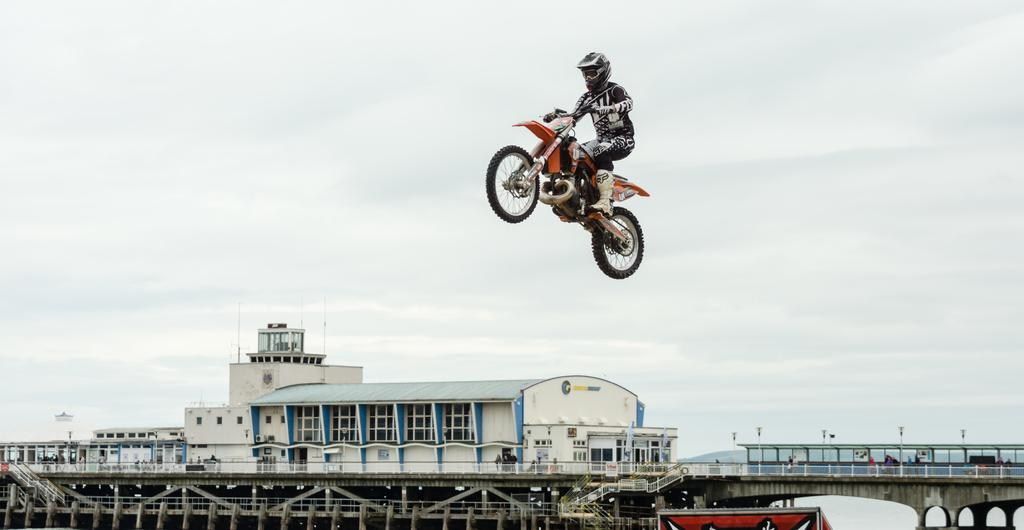What type of structures can be seen in the image? There are buildings in the image. What activity is a person performing in the image? A person is jumping with a motorbike in the image. What architectural elements are present in the image? There are pillars and poles in the image. What can be seen in the distance in the image? The sky is visible in the background of the image. How many grapes are hanging from the pillars in the image? There are no grapes present in the image; it features buildings, a person jumping with a motorbike, pillars, poles, and a visible sky. What direction does the air flow in the image? There is no indication of air flow in the image. 